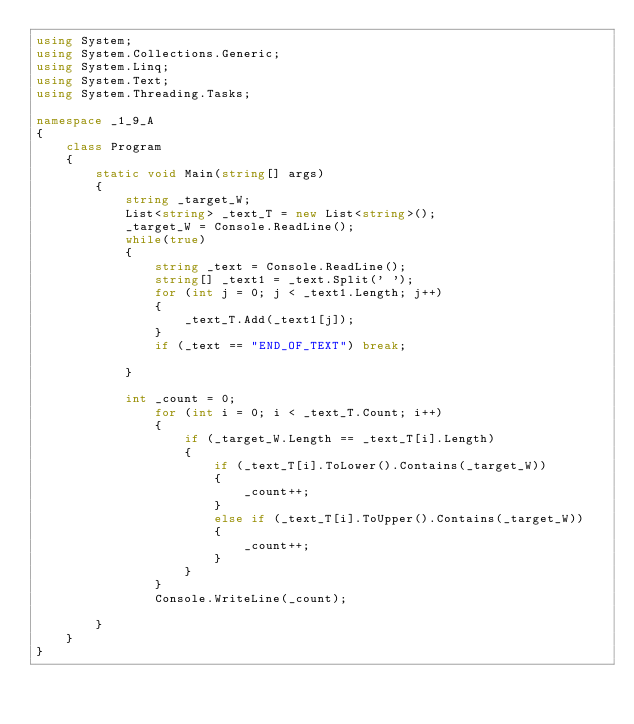<code> <loc_0><loc_0><loc_500><loc_500><_C#_>using System;
using System.Collections.Generic;
using System.Linq;
using System.Text;
using System.Threading.Tasks;

namespace _1_9_A
{
    class Program
    {
        static void Main(string[] args)
        {
            string _target_W;
            List<string> _text_T = new List<string>();
            _target_W = Console.ReadLine();
            while(true)
            {
                string _text = Console.ReadLine();
                string[] _text1 = _text.Split(' ');
                for (int j = 0; j < _text1.Length; j++)
                {
                    _text_T.Add(_text1[j]);
                }
                if (_text == "END_OF_TEXT") break;

            }

            int _count = 0;
                for (int i = 0; i < _text_T.Count; i++)
                {
                    if (_target_W.Length == _text_T[i].Length)
                    {
                        if (_text_T[i].ToLower().Contains(_target_W))
                        {
                            _count++;
                        }
                        else if (_text_T[i].ToUpper().Contains(_target_W))
                        {
                            _count++;
                        }
                    }
                }
                Console.WriteLine(_count);
            
        }
    }
}
</code> 